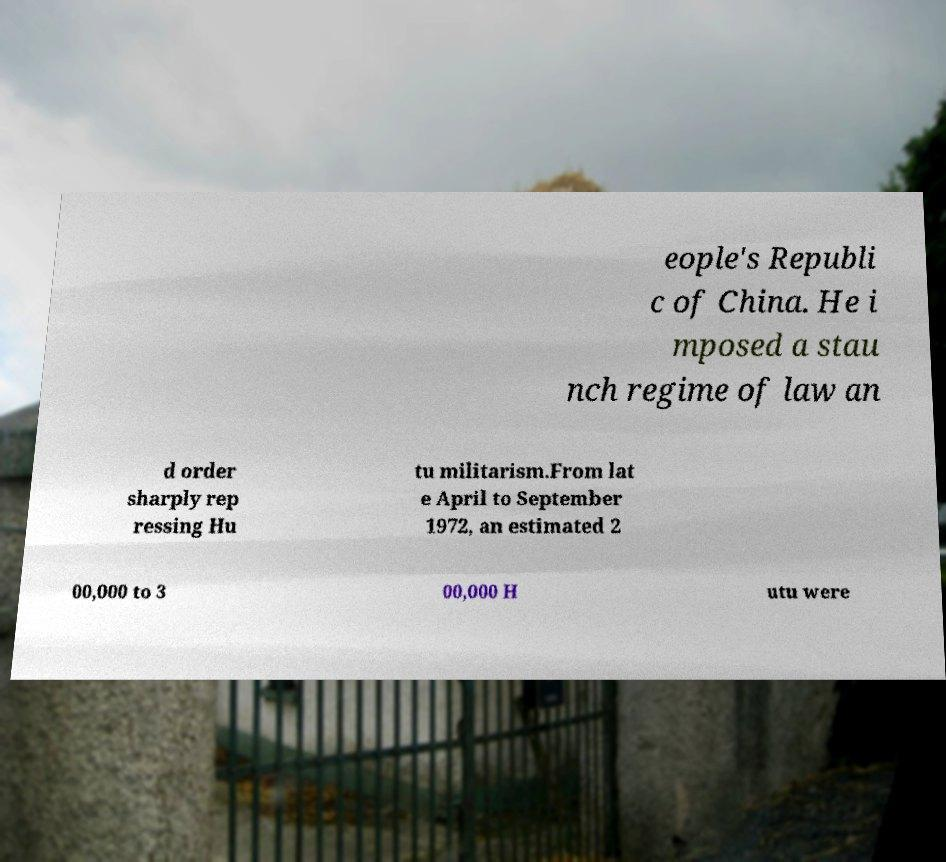Please identify and transcribe the text found in this image. eople's Republi c of China. He i mposed a stau nch regime of law an d order sharply rep ressing Hu tu militarism.From lat e April to September 1972, an estimated 2 00,000 to 3 00,000 H utu were 